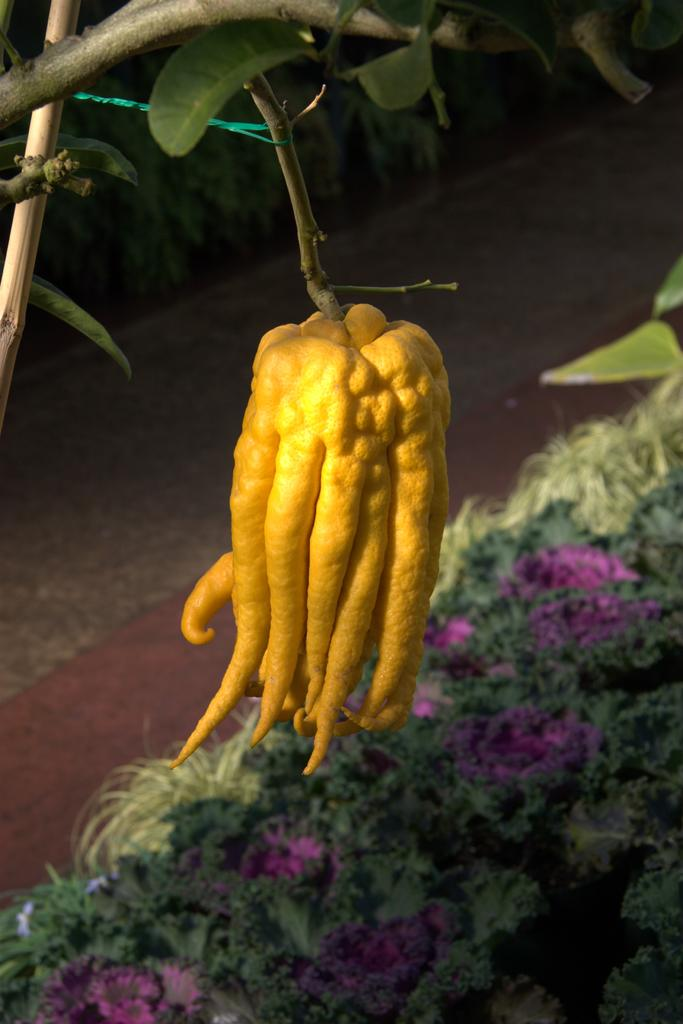What type of food item is present in the image? There is a fruit in the image. How is the fruit connected to the plant? The fruit is attached to a stem. What can be seen in the background of the image? There are plants and a pathway in the background of the image. What type of zinc is visible on the fruit in the image? There is no zinc present in the image; it is a fruit attached to a stem with plants and a pathway in the background. 